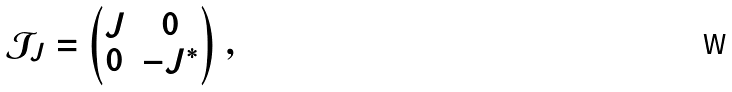<formula> <loc_0><loc_0><loc_500><loc_500>\mathcal { J } _ { J } = \begin{pmatrix} J & 0 \\ 0 & - J ^ { \ast } \end{pmatrix} \, ,</formula> 